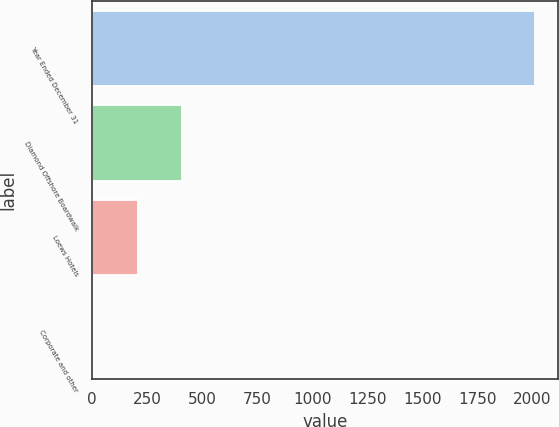<chart> <loc_0><loc_0><loc_500><loc_500><bar_chart><fcel>Year Ended December 31<fcel>Diamond Offshore Boardwalk<fcel>Loews Hotels<fcel>Corporate and other<nl><fcel>2015<fcel>407.8<fcel>206.9<fcel>6<nl></chart> 